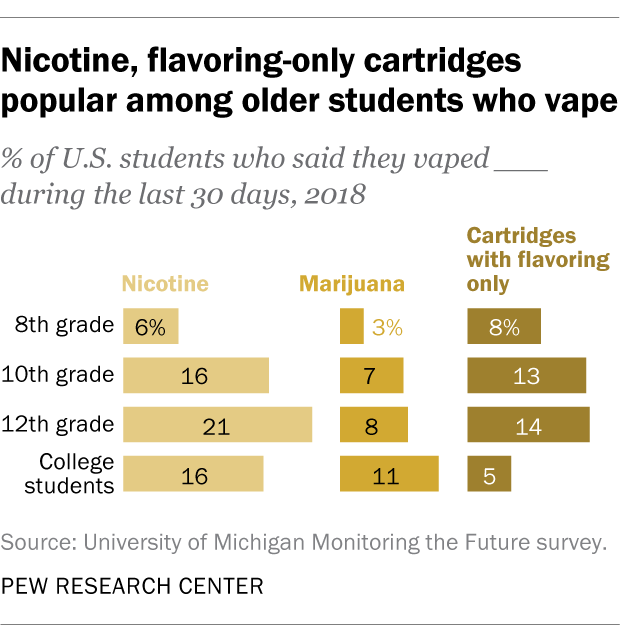Give some essential details in this illustration. A recent study has revealed that 6% of 8th-grade students have used nicotine. According to the chart, 12th graders are the most likely group to vape. 